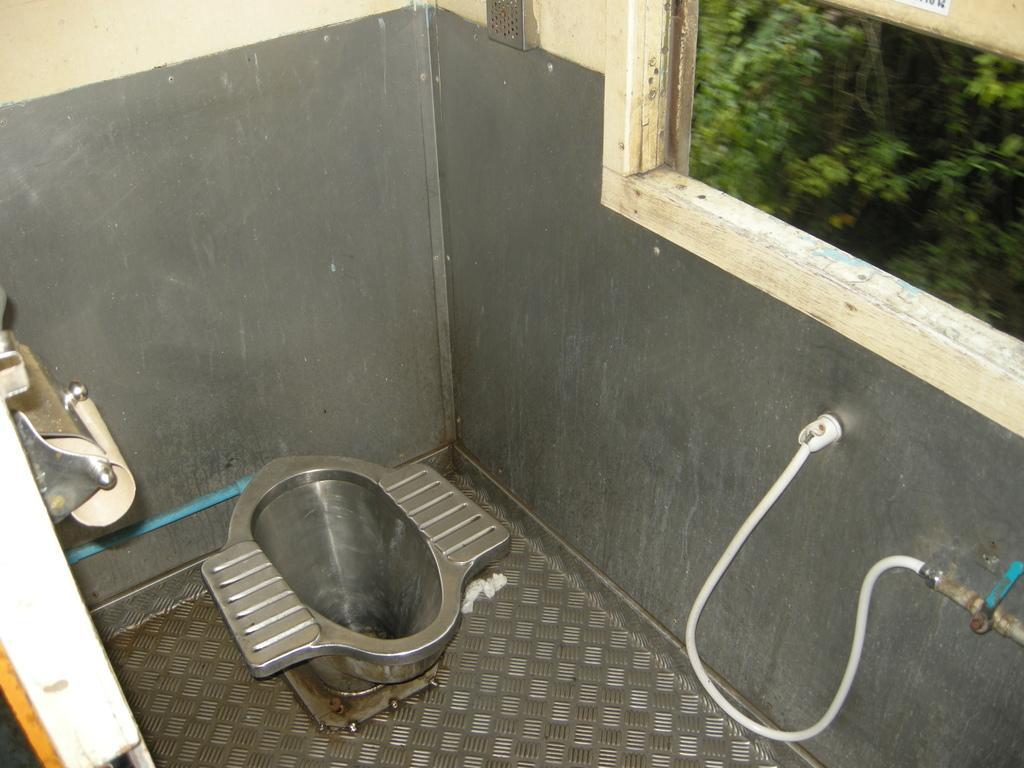In one or two sentences, can you explain what this image depicts? In the center of the image we can see a toilet seat. On the right there is a tap and pipe. On the left there is a door. In the background there is a wall and we can see a window. 